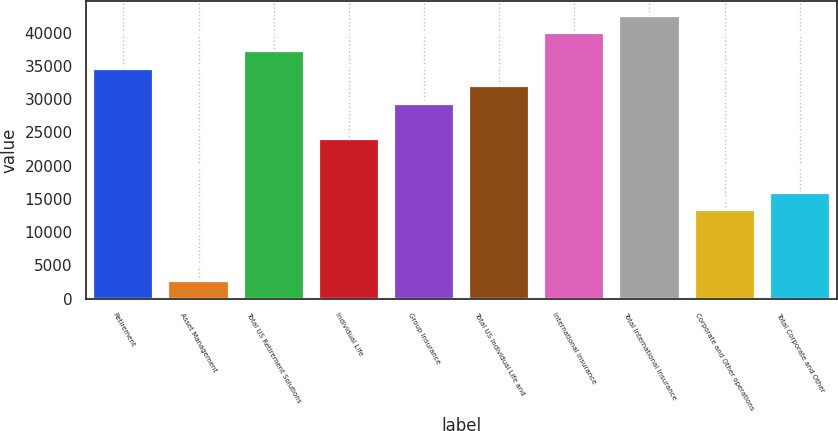Convert chart. <chart><loc_0><loc_0><loc_500><loc_500><bar_chart><fcel>Retirement<fcel>Asset Management<fcel>Total US Retirement Solutions<fcel>Individual Life<fcel>Group Insurance<fcel>Total US Individual Life and<fcel>International Insurance<fcel>Total International Insurance<fcel>Corporate and Other operations<fcel>Total Corporate and Other<nl><fcel>34600.5<fcel>2662.29<fcel>37262.1<fcel>23954.5<fcel>29277.5<fcel>31939<fcel>39923.6<fcel>42585.1<fcel>13308.4<fcel>15969.9<nl></chart> 